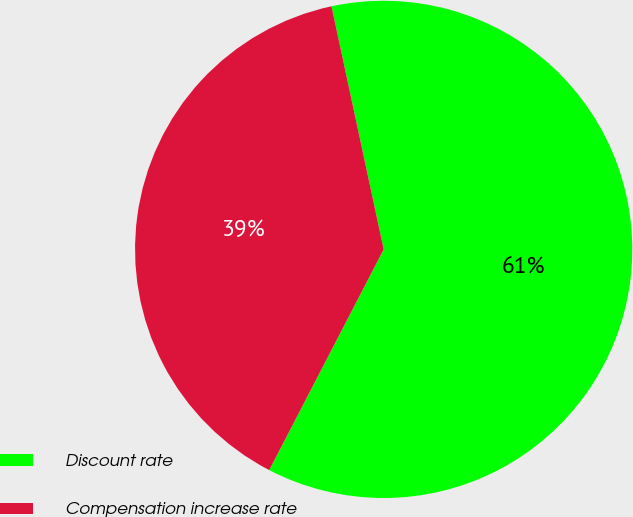<chart> <loc_0><loc_0><loc_500><loc_500><pie_chart><fcel>Discount rate<fcel>Compensation increase rate<nl><fcel>60.98%<fcel>39.02%<nl></chart> 